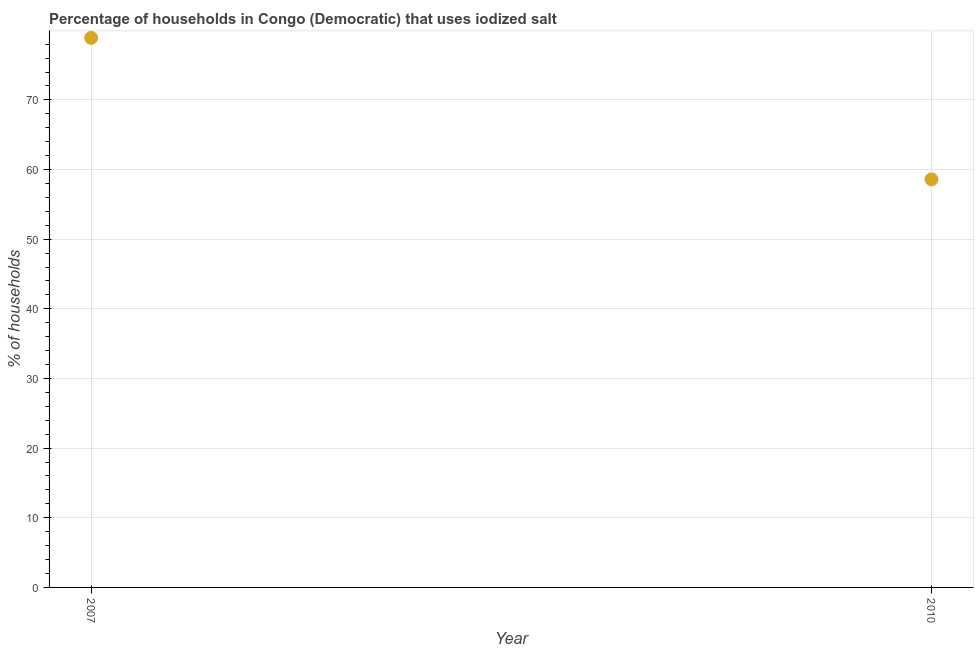What is the percentage of households where iodized salt is consumed in 2007?
Ensure brevity in your answer.  78.9. Across all years, what is the maximum percentage of households where iodized salt is consumed?
Ensure brevity in your answer.  78.9. Across all years, what is the minimum percentage of households where iodized salt is consumed?
Your answer should be compact. 58.6. In which year was the percentage of households where iodized salt is consumed minimum?
Offer a terse response. 2010. What is the sum of the percentage of households where iodized salt is consumed?
Your response must be concise. 137.5. What is the difference between the percentage of households where iodized salt is consumed in 2007 and 2010?
Give a very brief answer. 20.3. What is the average percentage of households where iodized salt is consumed per year?
Offer a very short reply. 68.75. What is the median percentage of households where iodized salt is consumed?
Offer a terse response. 68.75. In how many years, is the percentage of households where iodized salt is consumed greater than 36 %?
Your answer should be very brief. 2. What is the ratio of the percentage of households where iodized salt is consumed in 2007 to that in 2010?
Keep it short and to the point. 1.35. Is the percentage of households where iodized salt is consumed in 2007 less than that in 2010?
Provide a succinct answer. No. In how many years, is the percentage of households where iodized salt is consumed greater than the average percentage of households where iodized salt is consumed taken over all years?
Give a very brief answer. 1. Does the percentage of households where iodized salt is consumed monotonically increase over the years?
Provide a short and direct response. No. How many dotlines are there?
Ensure brevity in your answer.  1. What is the difference between two consecutive major ticks on the Y-axis?
Offer a very short reply. 10. What is the title of the graph?
Your response must be concise. Percentage of households in Congo (Democratic) that uses iodized salt. What is the label or title of the X-axis?
Provide a succinct answer. Year. What is the label or title of the Y-axis?
Your answer should be compact. % of households. What is the % of households in 2007?
Your answer should be very brief. 78.9. What is the % of households in 2010?
Provide a succinct answer. 58.6. What is the difference between the % of households in 2007 and 2010?
Give a very brief answer. 20.3. What is the ratio of the % of households in 2007 to that in 2010?
Your answer should be very brief. 1.35. 